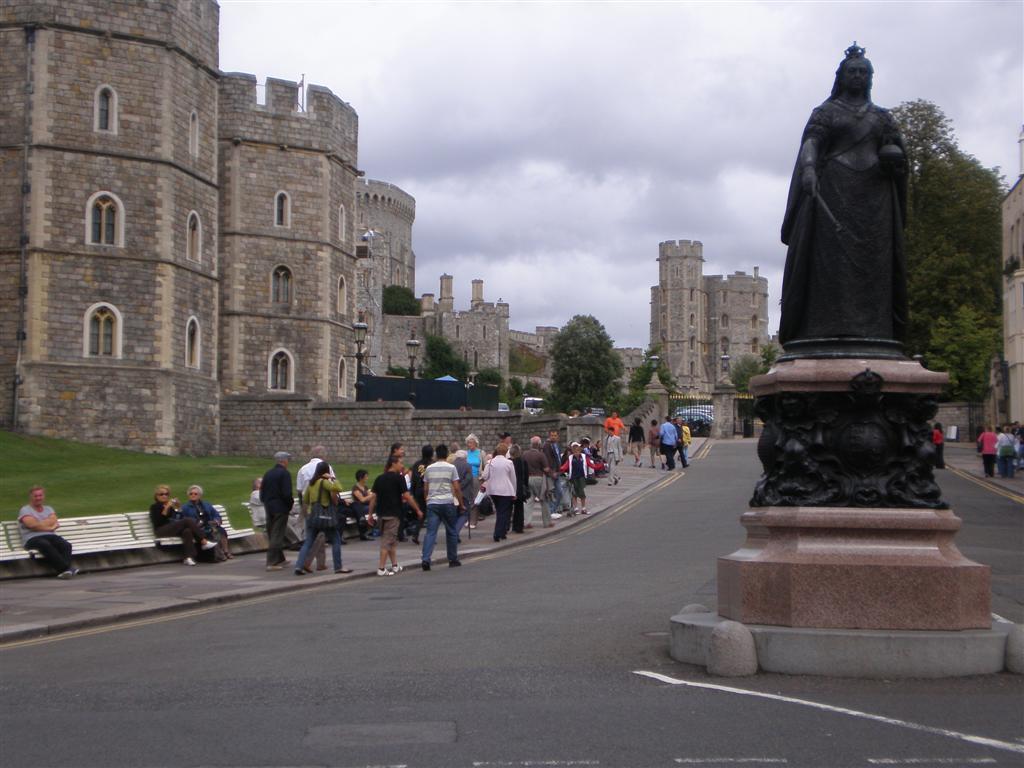Can you describe this image briefly? In this image there are buildings, light poles, trees, cloudy sky, statue, grass, benches, people, road and objects. Among them few people are sitting on benches.   